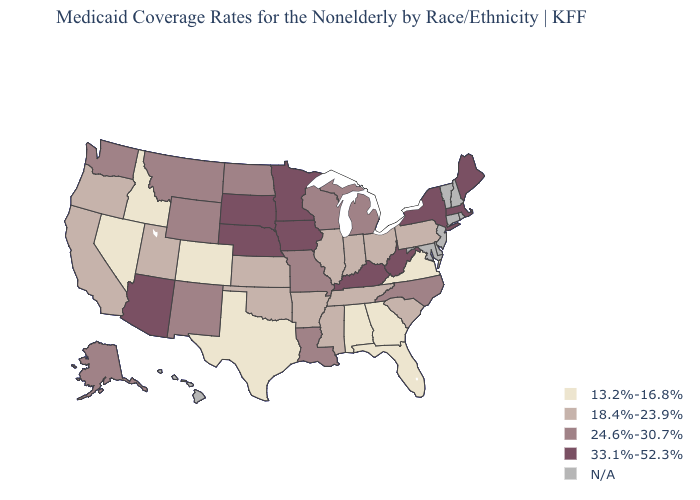What is the value of Arkansas?
Concise answer only. 18.4%-23.9%. Name the states that have a value in the range 24.6%-30.7%?
Keep it brief. Alaska, Louisiana, Michigan, Missouri, Montana, New Mexico, North Carolina, North Dakota, Washington, Wisconsin, Wyoming. Which states have the highest value in the USA?
Write a very short answer. Arizona, Iowa, Kentucky, Maine, Massachusetts, Minnesota, Nebraska, New York, South Dakota, West Virginia. What is the highest value in states that border Connecticut?
Quick response, please. 33.1%-52.3%. Name the states that have a value in the range 24.6%-30.7%?
Be succinct. Alaska, Louisiana, Michigan, Missouri, Montana, New Mexico, North Carolina, North Dakota, Washington, Wisconsin, Wyoming. Is the legend a continuous bar?
Quick response, please. No. Is the legend a continuous bar?
Be succinct. No. What is the highest value in the USA?
Be succinct. 33.1%-52.3%. Among the states that border Missouri , which have the highest value?
Answer briefly. Iowa, Kentucky, Nebraska. How many symbols are there in the legend?
Short answer required. 5. What is the lowest value in the USA?
Answer briefly. 13.2%-16.8%. What is the value of Arkansas?
Quick response, please. 18.4%-23.9%. What is the lowest value in the West?
Short answer required. 13.2%-16.8%. Which states have the lowest value in the Northeast?
Write a very short answer. Pennsylvania. What is the value of Ohio?
Give a very brief answer. 18.4%-23.9%. 